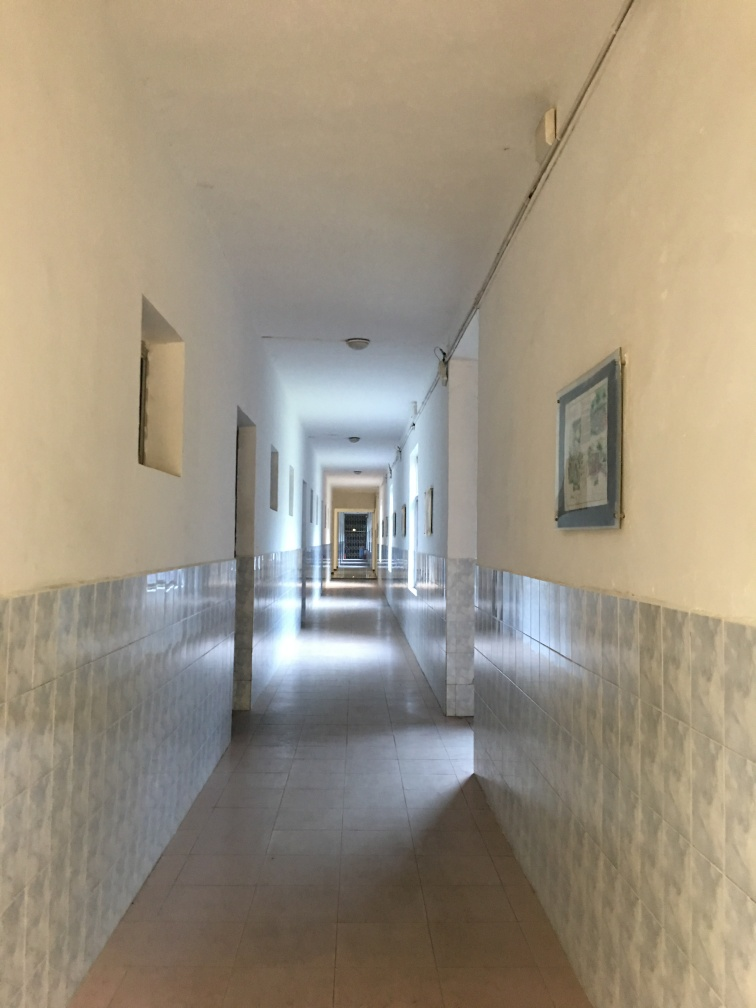How would you describe the lighting of the photo? A. Dim. B. Bright. C. Harsh. The lighting in the photo is naturally soft and even, with a bright corridor illuminated by sunlight filtering in from the end and reflecting gently off the walls. This diffused light creates a tranquil and inviting atmosphere, contrasting any harsh lighting, which typically creates sharp, strong shadows. There's a delicate balance between light and shadow that gives the space depth without overwhelming brightness, so I would describe the lighting as generally bright but not harsh. 